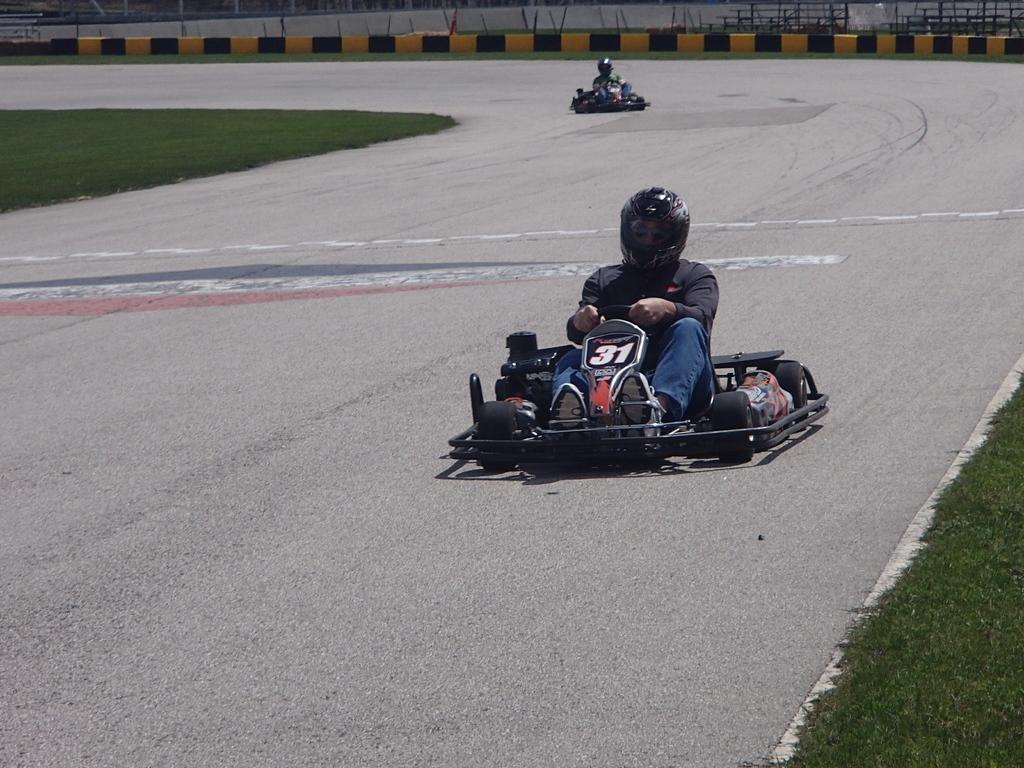What is the main subject in the foreground of the picture? There is a go-kart in the foreground of the picture. Can you describe the person in the foreground of the picture? There is a person in the foreground of the picture. What type of surface is visible in the foreground of the picture? There is a road and grass in the foreground of the picture. What can be seen in the background of the picture? There is a go-kart, fencing, and grass in the background of the picture. Are there any other people visible in the picture? Yes, there is a person in the background of the picture. What type of leather is being used to make the children's cubs in the image? There are no children or cubs present in the image, so it is not possible to determine what type of leather might be used. 